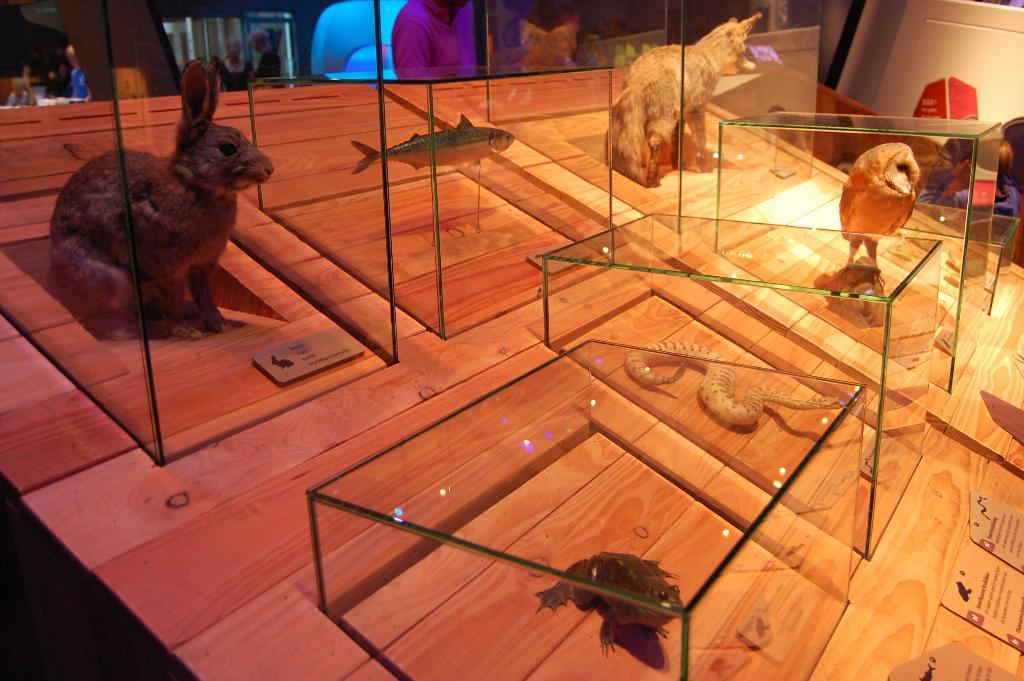What is the main object in the image? There is a wooden board in the image. What is placed on the wooden board? There are glass boxes on the wooden board. What can be found inside the glass boxes? There are animals inside the glass boxes. How many beds are visible in the image? There are no beds visible in the image. What type of pie is being served in the glass boxes? There is no pie present in the image; it features animals inside glass boxes on a wooden board. 